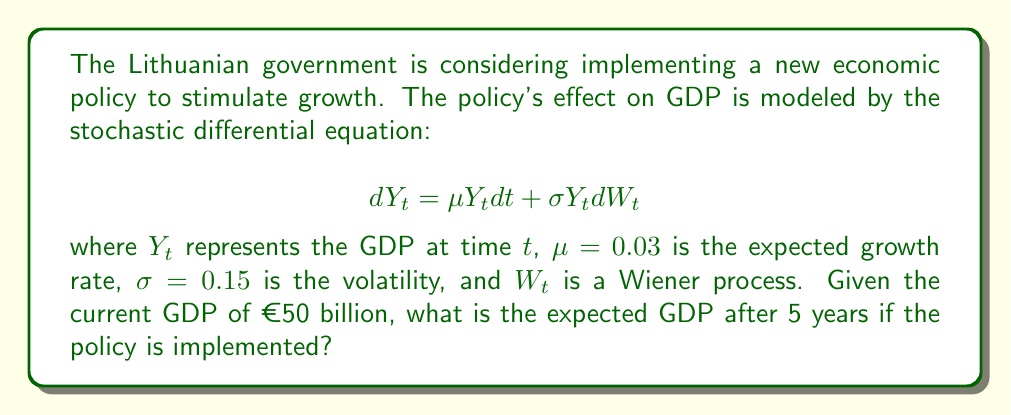Can you solve this math problem? To solve this problem, we'll use Itô's lemma and the properties of geometric Brownian motion:

1) The SDE given describes geometric Brownian motion.

2) For geometric Brownian motion, the solution for the expected value of $Y_t$ is given by:

   $$E[Y_t] = Y_0 e^{\mu t}$$

   where $Y_0$ is the initial value.

3) In this case:
   - $Y_0 = €50$ billion
   - $\mu = 0.03$
   - $t = 5$ years

4) Substituting these values into the formula:

   $$E[Y_5] = 50 e^{0.03 \cdot 5}$$

5) Calculate:
   $$E[Y_5] = 50 e^{0.15} \approx 50 \cdot 1.1618 \approx 58.09$$

Therefore, the expected GDP after 5 years is approximately €58.09 billion.

Note: The volatility $\sigma$ doesn't affect the expected value in this model, but it would impact the variance of possible outcomes.
Answer: €58.09 billion 